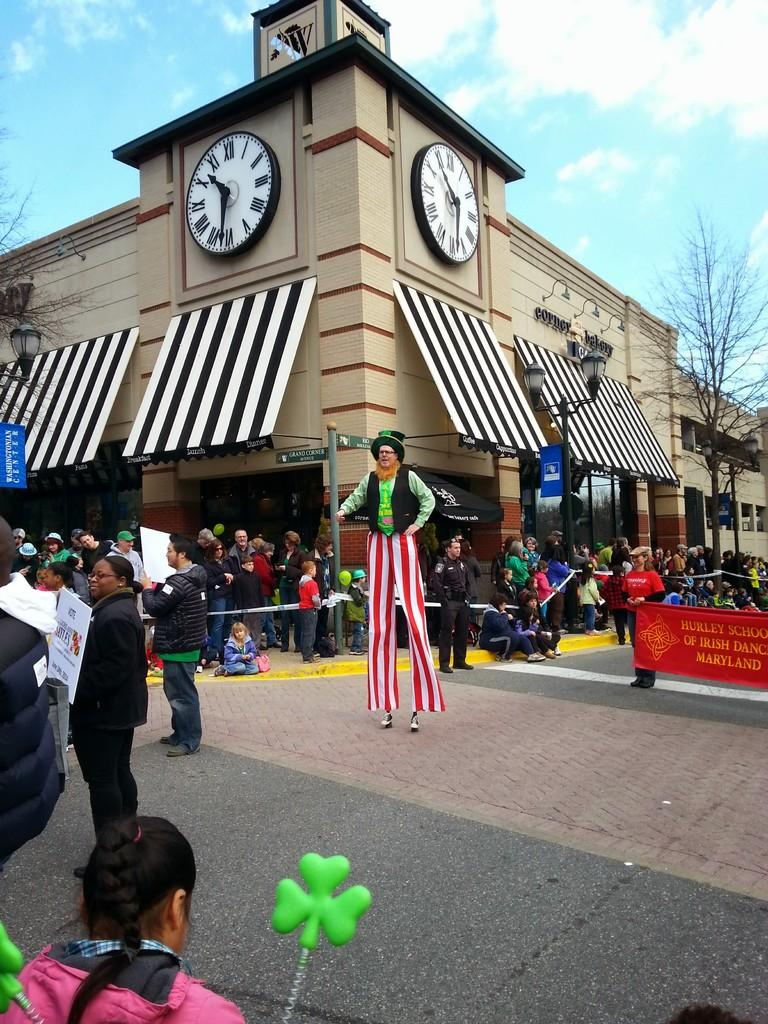Provide a one-sentence caption for the provided image. A parade takes place in town featuring the Hurley School of Irish Dance. 